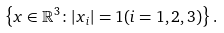<formula> <loc_0><loc_0><loc_500><loc_500>\left \{ x \in \mathbb { R } ^ { 3 } \colon | x _ { i } | = 1 ( i = 1 , 2 , 3 ) \right \} .</formula> 